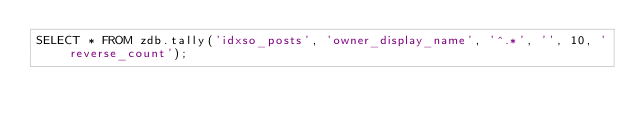<code> <loc_0><loc_0><loc_500><loc_500><_SQL_>SELECT * FROM zdb.tally('idxso_posts', 'owner_display_name', '^.*', '', 10, 'reverse_count');</code> 